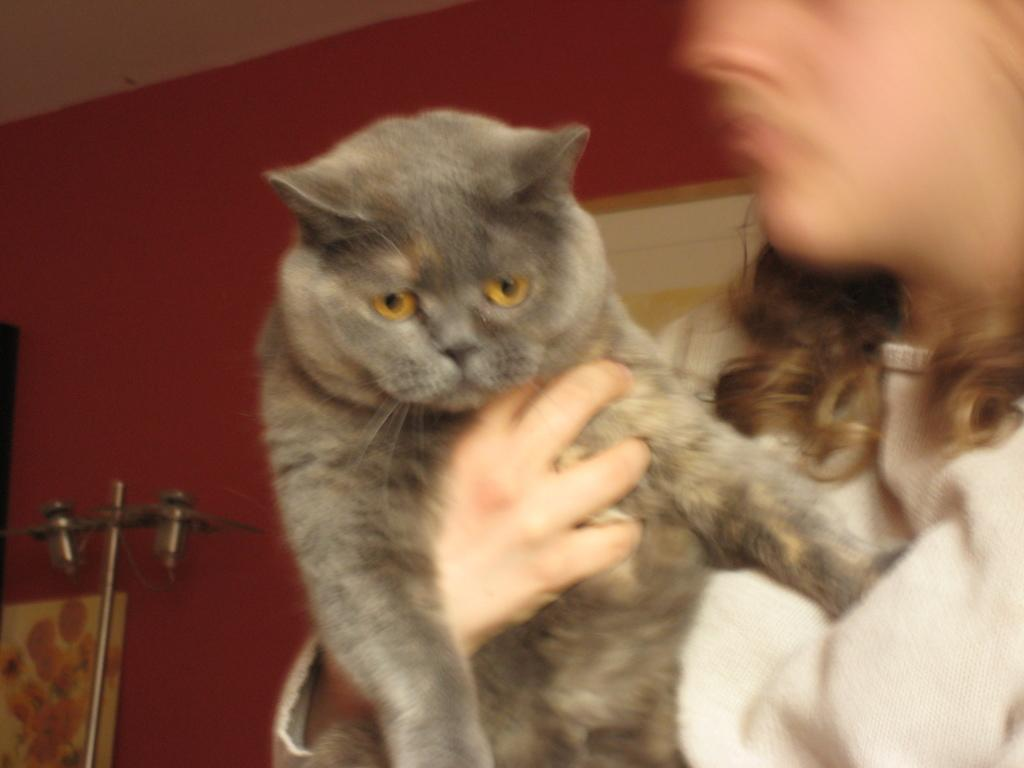Who or what is the main subject in the image? There is a person in the image. What is the person doing in the image? The person is catching a cat. How is the person catching the cat? The person is using their hands to catch the cat. What religion is the person practicing in the image? There is no indication of any religious practice in the image; it simply shows a person catching a cat. 